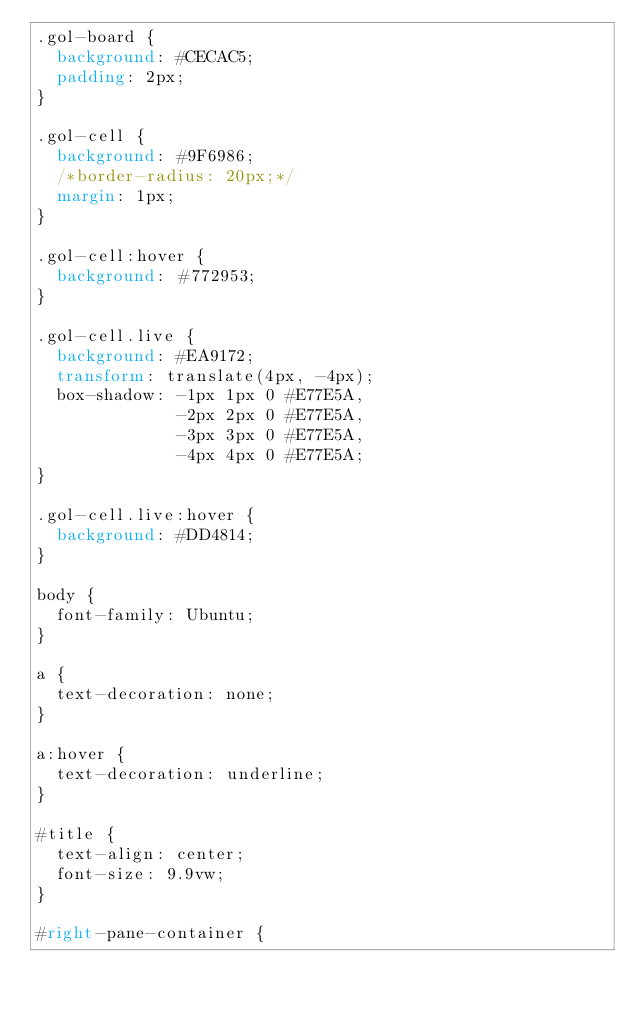Convert code to text. <code><loc_0><loc_0><loc_500><loc_500><_CSS_>.gol-board {
  background: #CECAC5;
  padding: 2px;
}

.gol-cell {
  background: #9F6986;
  /*border-radius: 20px;*/
  margin: 1px;
}

.gol-cell:hover {
  background: #772953;
}

.gol-cell.live {
  background: #EA9172;
  transform: translate(4px, -4px);
  box-shadow: -1px 1px 0 #E77E5A,
              -2px 2px 0 #E77E5A,
              -3px 3px 0 #E77E5A,
              -4px 4px 0 #E77E5A;
}

.gol-cell.live:hover {
  background: #DD4814;
}

body {
  font-family: Ubuntu;
}

a {
  text-decoration: none;
}

a:hover {
  text-decoration: underline;
}

#title {
  text-align: center;
  font-size: 9.9vw;
}

#right-pane-container {</code> 